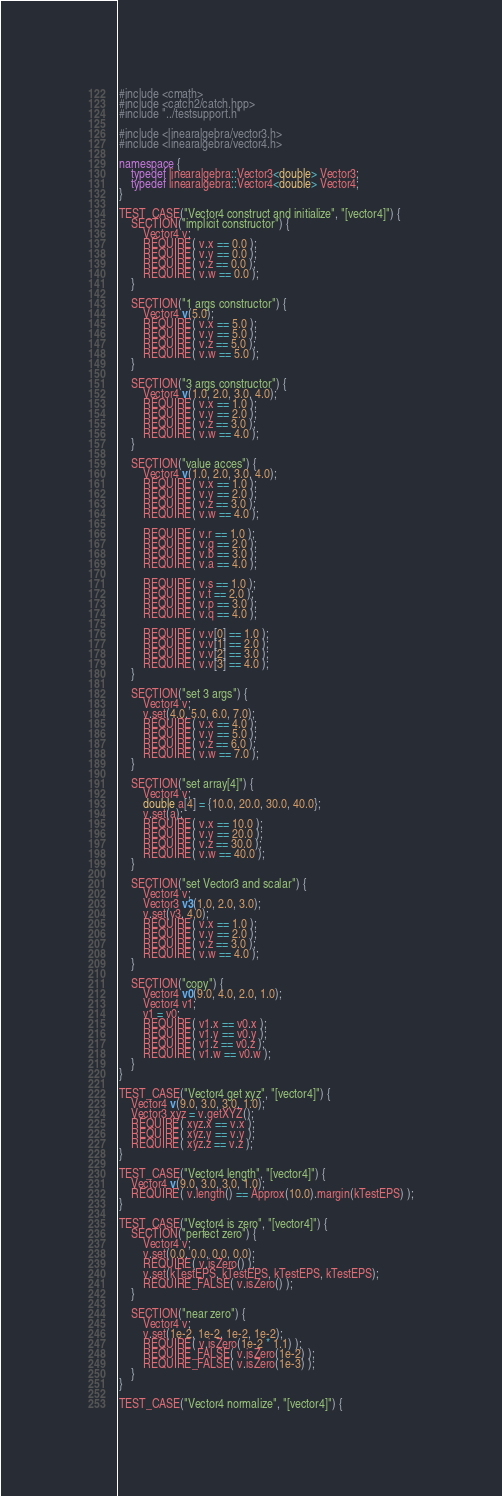<code> <loc_0><loc_0><loc_500><loc_500><_C++_>
#include <cmath>
#include <catch2/catch.hpp>
#include "../testsupport.h"

#include <linearalgebra/vector3.h>
#include <linearalgebra/vector4.h>

namespace {
    typedef linearalgebra::Vector3<double> Vector3;
    typedef linearalgebra::Vector4<double> Vector4;
}

TEST_CASE("Vector4 construct and initialize", "[vector4]") {
    SECTION("implicit constructor") {
        Vector4 v;
        REQUIRE( v.x == 0.0 );
        REQUIRE( v.y == 0.0 );
        REQUIRE( v.z == 0.0 );
        REQUIRE( v.w == 0.0 );
    }
    
    SECTION("1 args constructor") {
        Vector4 v(5.0);
        REQUIRE( v.x == 5.0 );
        REQUIRE( v.y == 5.0 );
        REQUIRE( v.z == 5.0 );
        REQUIRE( v.w == 5.0 );
    }
    
    SECTION("3 args constructor") {
        Vector4 v(1.0, 2.0, 3.0, 4.0);
        REQUIRE( v.x == 1.0 );
        REQUIRE( v.y == 2.0 );
        REQUIRE( v.z == 3.0 );
        REQUIRE( v.w == 4.0 );
    }
    
    SECTION("value acces") {
        Vector4 v(1.0, 2.0, 3.0, 4.0);
        REQUIRE( v.x == 1.0 );
        REQUIRE( v.y == 2.0 );
        REQUIRE( v.z == 3.0 );
        REQUIRE( v.w == 4.0 );
        
        REQUIRE( v.r == 1.0 );
        REQUIRE( v.g == 2.0 );
        REQUIRE( v.b == 3.0 );
        REQUIRE( v.a == 4.0 );
        
        REQUIRE( v.s == 1.0 );
        REQUIRE( v.t == 2.0 );
        REQUIRE( v.p == 3.0 );
        REQUIRE( v.q == 4.0 );
        
        REQUIRE( v.v[0] == 1.0 );
        REQUIRE( v.v[1] == 2.0 );
        REQUIRE( v.v[2] == 3.0 );
        REQUIRE( v.v[3] == 4.0 );
    }
    
    SECTION("set 3 args") {
        Vector4 v;
        v.set(4.0, 5.0, 6.0, 7.0);
        REQUIRE( v.x == 4.0 );
        REQUIRE( v.y == 5.0 );
        REQUIRE( v.z == 6.0 );
        REQUIRE( v.w == 7.0 );
    }
    
    SECTION("set array[4]") {
        Vector4 v;
        double a[4] = {10.0, 20.0, 30.0, 40.0};
        v.set(a);
        REQUIRE( v.x == 10.0 );
        REQUIRE( v.y == 20.0 );
        REQUIRE( v.z == 30.0 );
        REQUIRE( v.w == 40.0 );
    }
    
    SECTION("set Vector3 and scalar") {
        Vector4 v;
        Vector3 v3(1.0, 2.0, 3.0);
        v.set(v3, 4.0);
        REQUIRE( v.x == 1.0 );
        REQUIRE( v.y == 2.0 );
        REQUIRE( v.z == 3.0 );
        REQUIRE( v.w == 4.0 );
    }
    
    SECTION("copy") {
        Vector4 v0(9.0, 4.0, 2.0, 1.0);
        Vector4 v1;
        v1 = v0;
        REQUIRE( v1.x == v0.x );
        REQUIRE( v1.y == v0.y );
        REQUIRE( v1.z == v0.z );
        REQUIRE( v1.w == v0.w );
    }
}

TEST_CASE("Vector4 get xyz", "[vector4]") {
    Vector4 v(9.0, 3.0, 3.0, 1.0);
    Vector3 xyz = v.getXYZ();
    REQUIRE( xyz.x == v.x );
    REQUIRE( xyz.y == v.y );
    REQUIRE( xyz.z == v.z );
}

TEST_CASE("Vector4 length", "[vector4]") {
    Vector4 v(9.0, 3.0, 3.0, 1.0);
    REQUIRE( v.length() == Approx(10.0).margin(kTestEPS) );
}

TEST_CASE("Vector4 is zero", "[vector4]") {
    SECTION("perfect zero") {
        Vector4 v;
        v.set(0.0, 0.0, 0.0, 0.0);
        REQUIRE( v.isZero() );
        v.set(kTestEPS, kTestEPS, kTestEPS, kTestEPS);
        REQUIRE_FALSE( v.isZero() );
    }
    
    SECTION("near zero") {
        Vector4 v;
        v.set(1e-2, 1e-2, 1e-2, 1e-2);
        REQUIRE( v.isZero(1e-2 * 1.1) );
        REQUIRE_FALSE( v.isZero(1e-2) );
        REQUIRE_FALSE( v.isZero(1e-3) );
    }
}

TEST_CASE("Vector4 normalize", "[vector4]") {</code> 